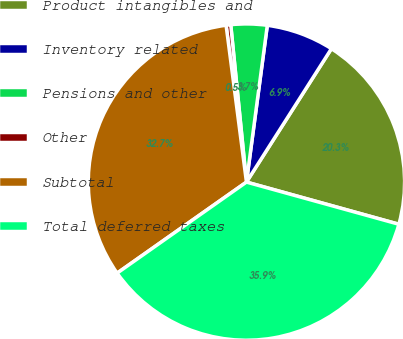<chart> <loc_0><loc_0><loc_500><loc_500><pie_chart><fcel>Product intangibles and<fcel>Inventory related<fcel>Pensions and other<fcel>Other<fcel>Subtotal<fcel>Total deferred taxes<nl><fcel>20.27%<fcel>6.92%<fcel>3.69%<fcel>0.47%<fcel>32.71%<fcel>35.94%<nl></chart> 